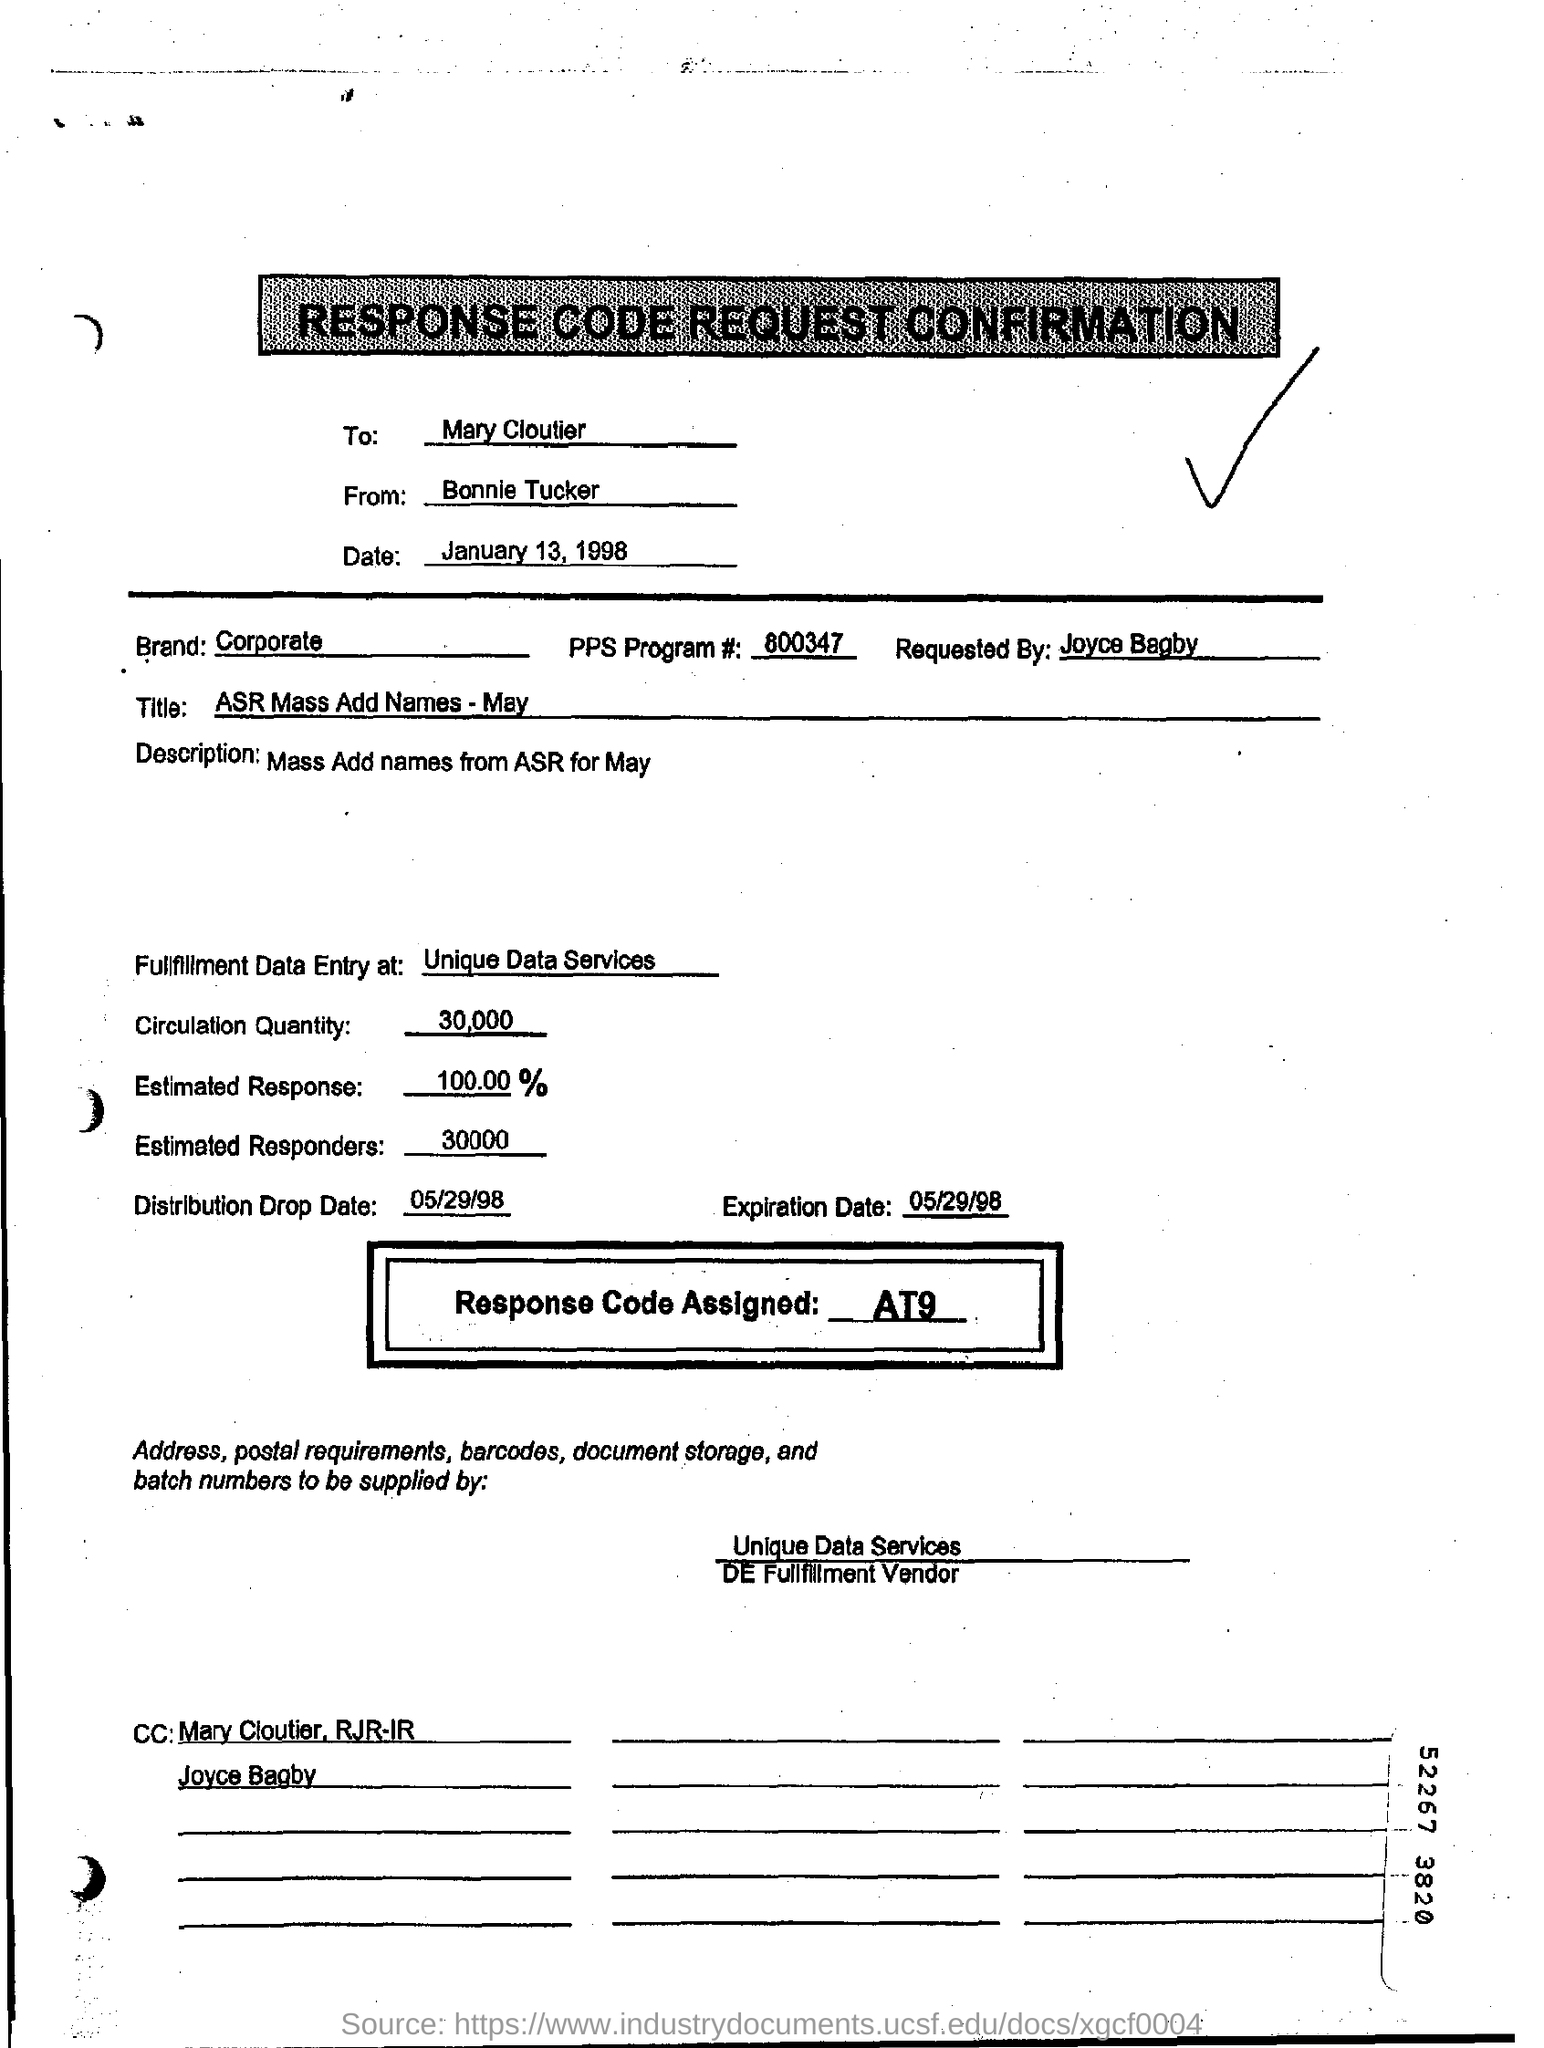Mention a couple of crucial points in this snapshot. The estimated response is 100.00%, indicating a high level of confidence in the outcome. The expiration date mentioned in this document is May 29, 1998. The sender of the document is Bonnie Tucker. The circulation quantity, as stated in the document, is 30,000. This is a response code request confirmation document. 